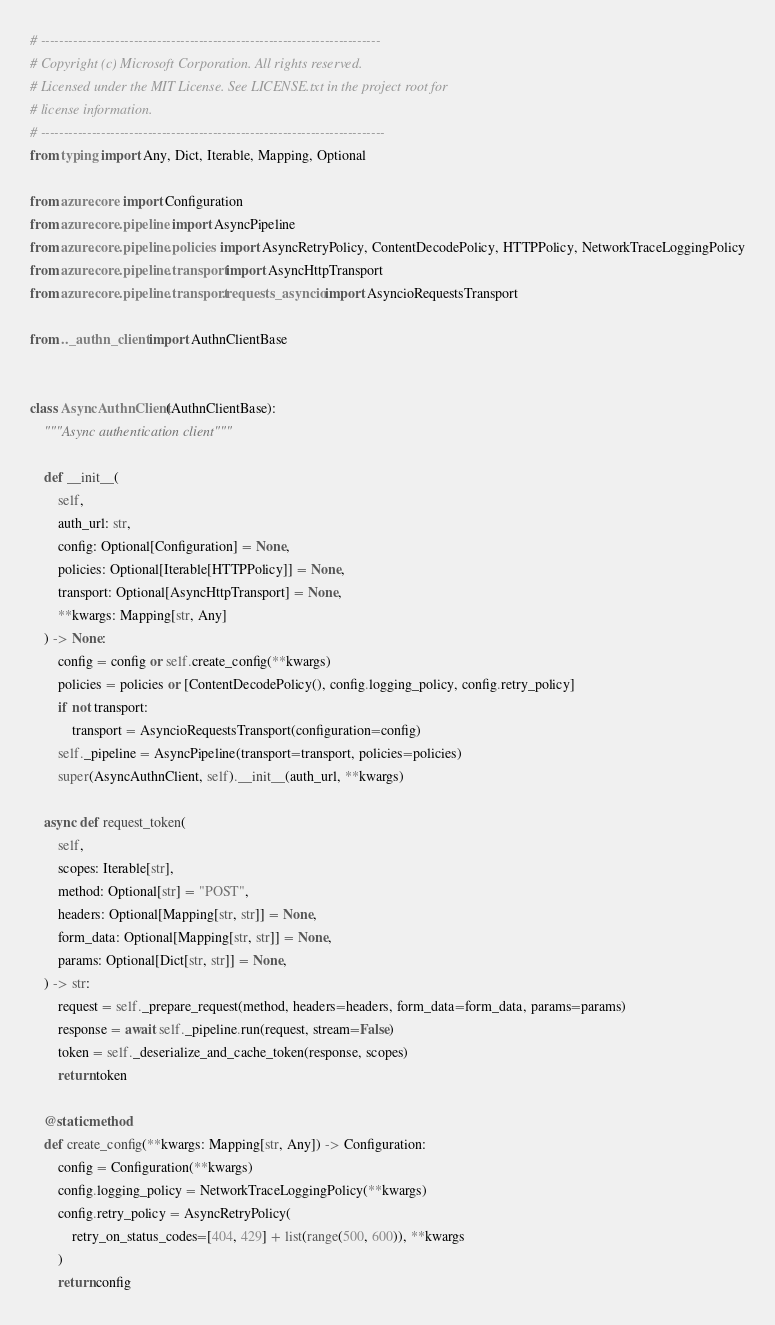Convert code to text. <code><loc_0><loc_0><loc_500><loc_500><_Python_># -------------------------------------------------------------------------
# Copyright (c) Microsoft Corporation. All rights reserved.
# Licensed under the MIT License. See LICENSE.txt in the project root for
# license information.
# --------------------------------------------------------------------------
from typing import Any, Dict, Iterable, Mapping, Optional

from azure.core import Configuration
from azure.core.pipeline import AsyncPipeline
from azure.core.pipeline.policies import AsyncRetryPolicy, ContentDecodePolicy, HTTPPolicy, NetworkTraceLoggingPolicy
from azure.core.pipeline.transport import AsyncHttpTransport
from azure.core.pipeline.transport.requests_asyncio import AsyncioRequestsTransport

from .._authn_client import AuthnClientBase


class AsyncAuthnClient(AuthnClientBase):
    """Async authentication client"""

    def __init__(
        self,
        auth_url: str,
        config: Optional[Configuration] = None,
        policies: Optional[Iterable[HTTPPolicy]] = None,
        transport: Optional[AsyncHttpTransport] = None,
        **kwargs: Mapping[str, Any]
    ) -> None:
        config = config or self.create_config(**kwargs)
        policies = policies or [ContentDecodePolicy(), config.logging_policy, config.retry_policy]
        if not transport:
            transport = AsyncioRequestsTransport(configuration=config)
        self._pipeline = AsyncPipeline(transport=transport, policies=policies)
        super(AsyncAuthnClient, self).__init__(auth_url, **kwargs)

    async def request_token(
        self,
        scopes: Iterable[str],
        method: Optional[str] = "POST",
        headers: Optional[Mapping[str, str]] = None,
        form_data: Optional[Mapping[str, str]] = None,
        params: Optional[Dict[str, str]] = None,
    ) -> str:
        request = self._prepare_request(method, headers=headers, form_data=form_data, params=params)
        response = await self._pipeline.run(request, stream=False)
        token = self._deserialize_and_cache_token(response, scopes)
        return token

    @staticmethod
    def create_config(**kwargs: Mapping[str, Any]) -> Configuration:
        config = Configuration(**kwargs)
        config.logging_policy = NetworkTraceLoggingPolicy(**kwargs)
        config.retry_policy = AsyncRetryPolicy(
            retry_on_status_codes=[404, 429] + list(range(500, 600)), **kwargs
        )
        return config
</code> 